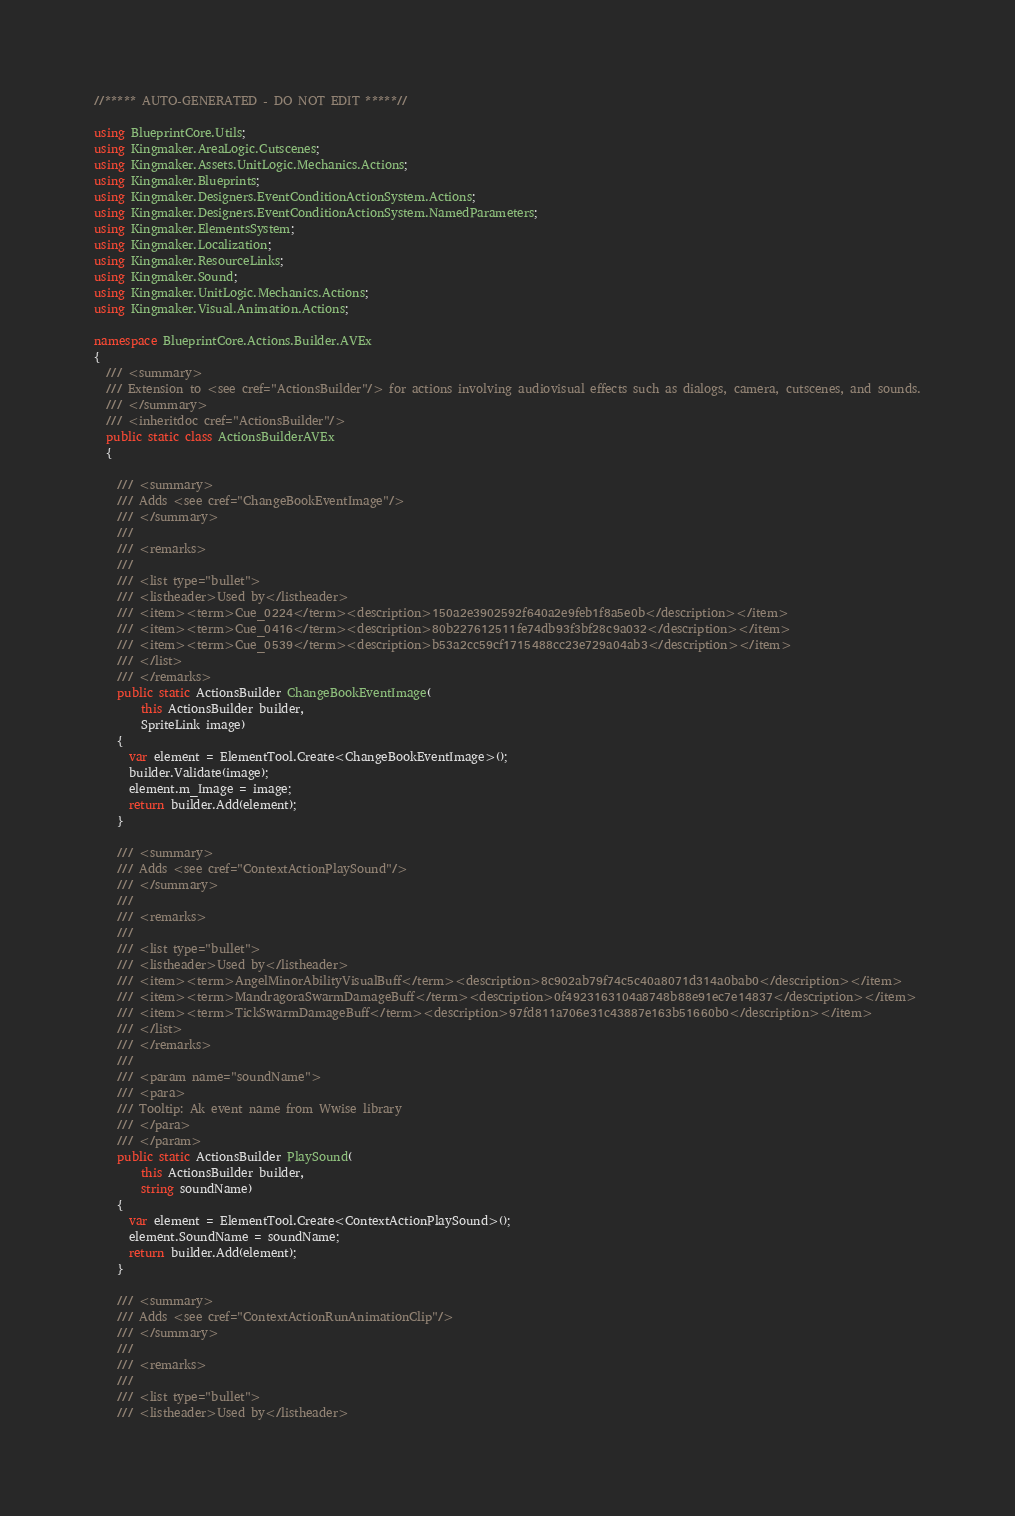<code> <loc_0><loc_0><loc_500><loc_500><_C#_>//***** AUTO-GENERATED - DO NOT EDIT *****//

using BlueprintCore.Utils;
using Kingmaker.AreaLogic.Cutscenes;
using Kingmaker.Assets.UnitLogic.Mechanics.Actions;
using Kingmaker.Blueprints;
using Kingmaker.Designers.EventConditionActionSystem.Actions;
using Kingmaker.Designers.EventConditionActionSystem.NamedParameters;
using Kingmaker.ElementsSystem;
using Kingmaker.Localization;
using Kingmaker.ResourceLinks;
using Kingmaker.Sound;
using Kingmaker.UnitLogic.Mechanics.Actions;
using Kingmaker.Visual.Animation.Actions;

namespace BlueprintCore.Actions.Builder.AVEx
{
  /// <summary>
  /// Extension to <see cref="ActionsBuilder"/> for actions involving audiovisual effects such as dialogs, camera, cutscenes, and sounds.
  /// </summary>
  /// <inheritdoc cref="ActionsBuilder"/>
  public static class ActionsBuilderAVEx
  {

    /// <summary>
    /// Adds <see cref="ChangeBookEventImage"/>
    /// </summary>
    ///
    /// <remarks>
    ///
    /// <list type="bullet">
    /// <listheader>Used by</listheader>
    /// <item><term>Cue_0224</term><description>150a2e3902592f640a2e9feb1f8a5e0b</description></item>
    /// <item><term>Cue_0416</term><description>80b227612511fe74db93f3bf28c9a032</description></item>
    /// <item><term>Cue_0539</term><description>b53a2cc59cf1715488cc23e729a04ab3</description></item>
    /// </list>
    /// </remarks>
    public static ActionsBuilder ChangeBookEventImage(
        this ActionsBuilder builder,
        SpriteLink image)
    {
      var element = ElementTool.Create<ChangeBookEventImage>();
      builder.Validate(image);
      element.m_Image = image;
      return builder.Add(element);
    }

    /// <summary>
    /// Adds <see cref="ContextActionPlaySound"/>
    /// </summary>
    ///
    /// <remarks>
    ///
    /// <list type="bullet">
    /// <listheader>Used by</listheader>
    /// <item><term>AngelMinorAbilityVisualBuff</term><description>8c902ab79f74c5c40a8071d314a0bab0</description></item>
    /// <item><term>MandragoraSwarmDamageBuff</term><description>0f4923163104a8748b88e91ec7e14837</description></item>
    /// <item><term>TickSwarmDamageBuff</term><description>97fd811a706e31c43887e163b51660b0</description></item>
    /// </list>
    /// </remarks>
    ///
    /// <param name="soundName">
    /// <para>
    /// Tooltip: Ak event name from Wwise library
    /// </para>
    /// </param>
    public static ActionsBuilder PlaySound(
        this ActionsBuilder builder,
        string soundName)
    {
      var element = ElementTool.Create<ContextActionPlaySound>();
      element.SoundName = soundName;
      return builder.Add(element);
    }

    /// <summary>
    /// Adds <see cref="ContextActionRunAnimationClip"/>
    /// </summary>
    ///
    /// <remarks>
    ///
    /// <list type="bullet">
    /// <listheader>Used by</listheader></code> 